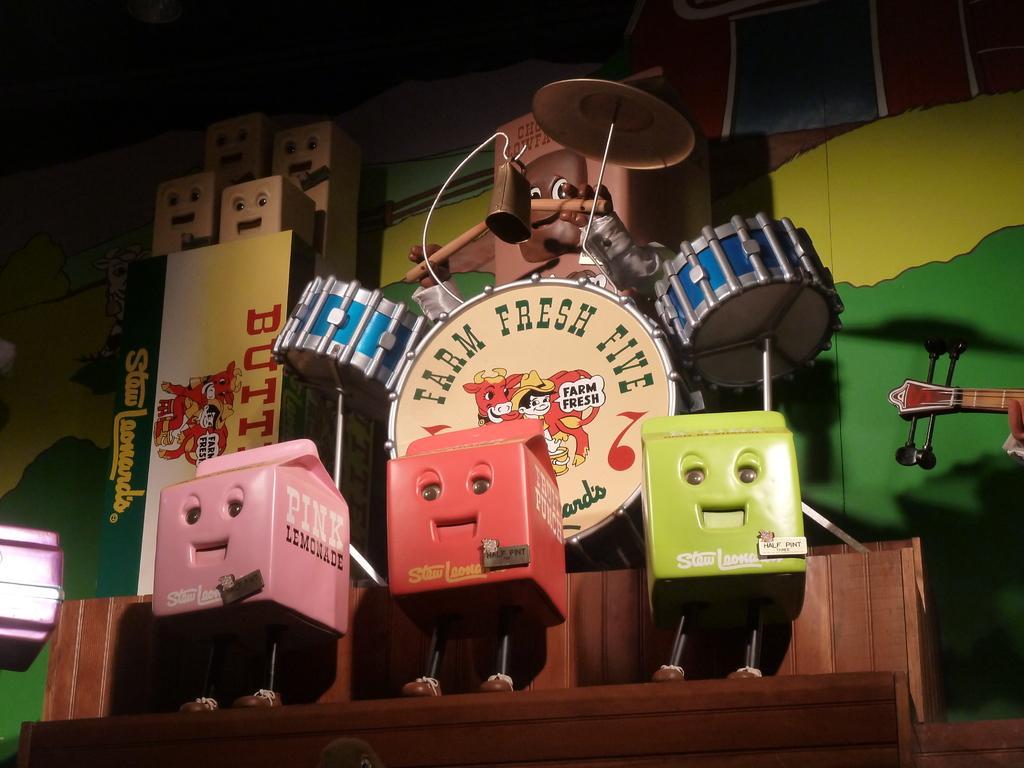In one or two sentences, can you explain what this image depicts? In this images we can see cartoon images on the platform. In the background there are musical instruments, drums, cartoon images and a cartoon image is holding sticks in the hands, paintings on the wall and there is a guitar on the right side. 